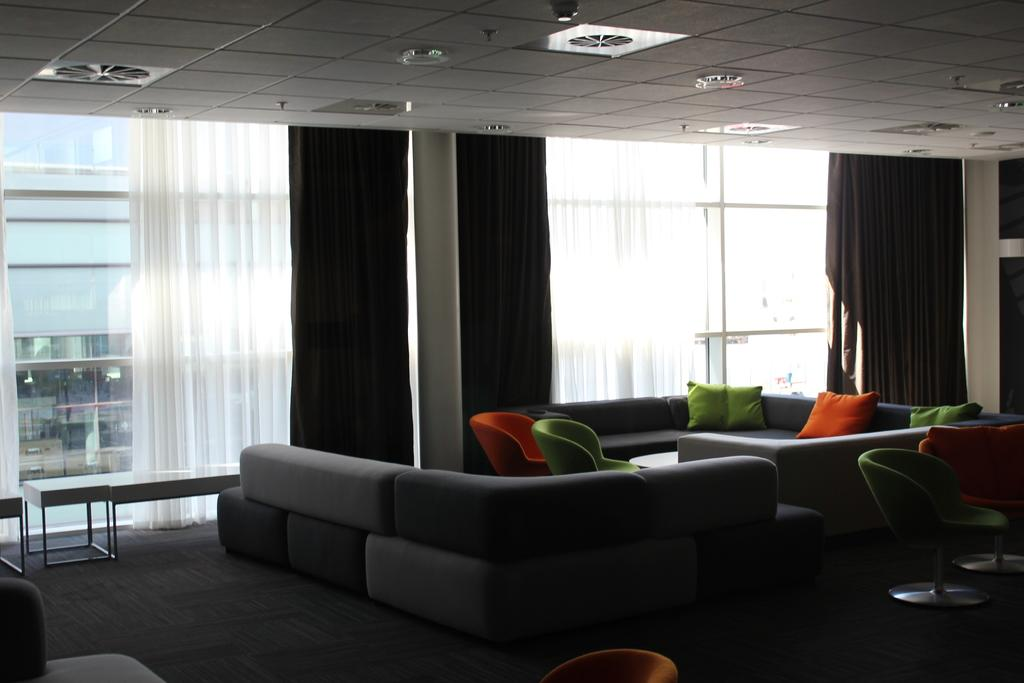What type of furniture is present in the image? There is a sofa and chairs in the image. What can be seen on the windows in the image? The curtains are in white and black color. What type of unit is being used to cook the stew in the image? There is no stew or cooking unit present in the image; it only features a sofa, chairs, and curtains. 